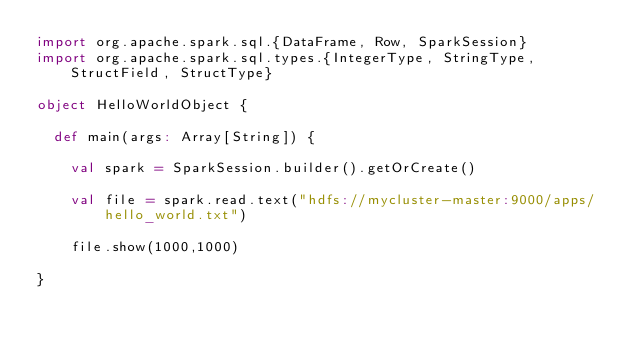Convert code to text. <code><loc_0><loc_0><loc_500><loc_500><_Scala_>import org.apache.spark.sql.{DataFrame, Row, SparkSession}
import org.apache.spark.sql.types.{IntegerType, StringType, StructField, StructType}

object HelloWorldObject {

  def main(args: Array[String]) {

    val spark = SparkSession.builder().getOrCreate()

    val file = spark.read.text("hdfs://mycluster-master:9000/apps/hello_world.txt")

    file.show(1000,1000)

}
</code> 